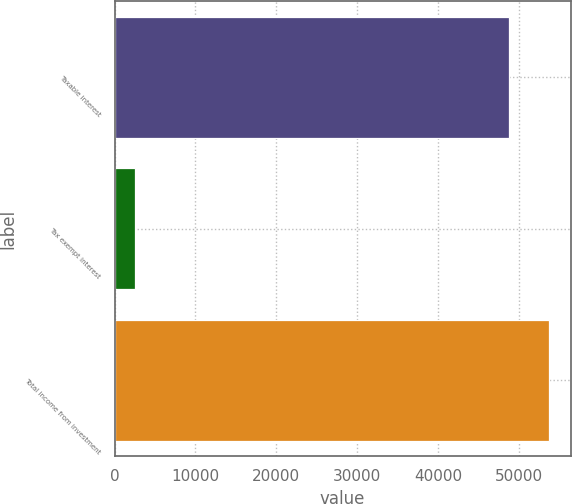Convert chart to OTSL. <chart><loc_0><loc_0><loc_500><loc_500><bar_chart><fcel>Taxable interest<fcel>Tax exempt interest<fcel>Total income from investment<nl><fcel>48787<fcel>2489<fcel>53672.6<nl></chart> 